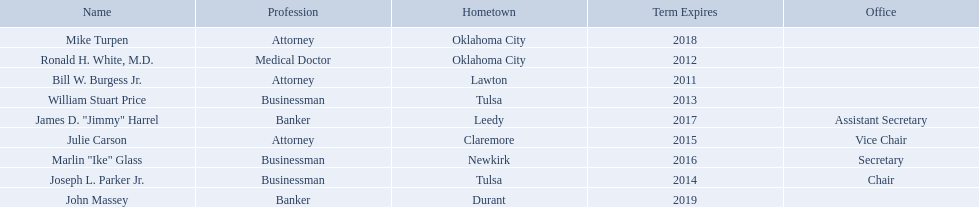What businessmen were born in tulsa? William Stuart Price, Joseph L. Parker Jr. Which man, other than price, was born in tulsa? Joseph L. Parker Jr. What are all the names of oklahoma state regents for higher educations? Bill W. Burgess Jr., Ronald H. White, M.D., William Stuart Price, Joseph L. Parker Jr., Julie Carson, Marlin "Ike" Glass, James D. "Jimmy" Harrel, Mike Turpen, John Massey. Which ones are businessmen? William Stuart Price, Joseph L. Parker Jr., Marlin "Ike" Glass. Of those, who is from tulsa? William Stuart Price, Joseph L. Parker Jr. Whose term expires in 2014? Joseph L. Parker Jr. Where is bill w. burgess jr. from? Lawton. Where is price and parker from? Tulsa. Who is from the same state as white? Mike Turpen. 